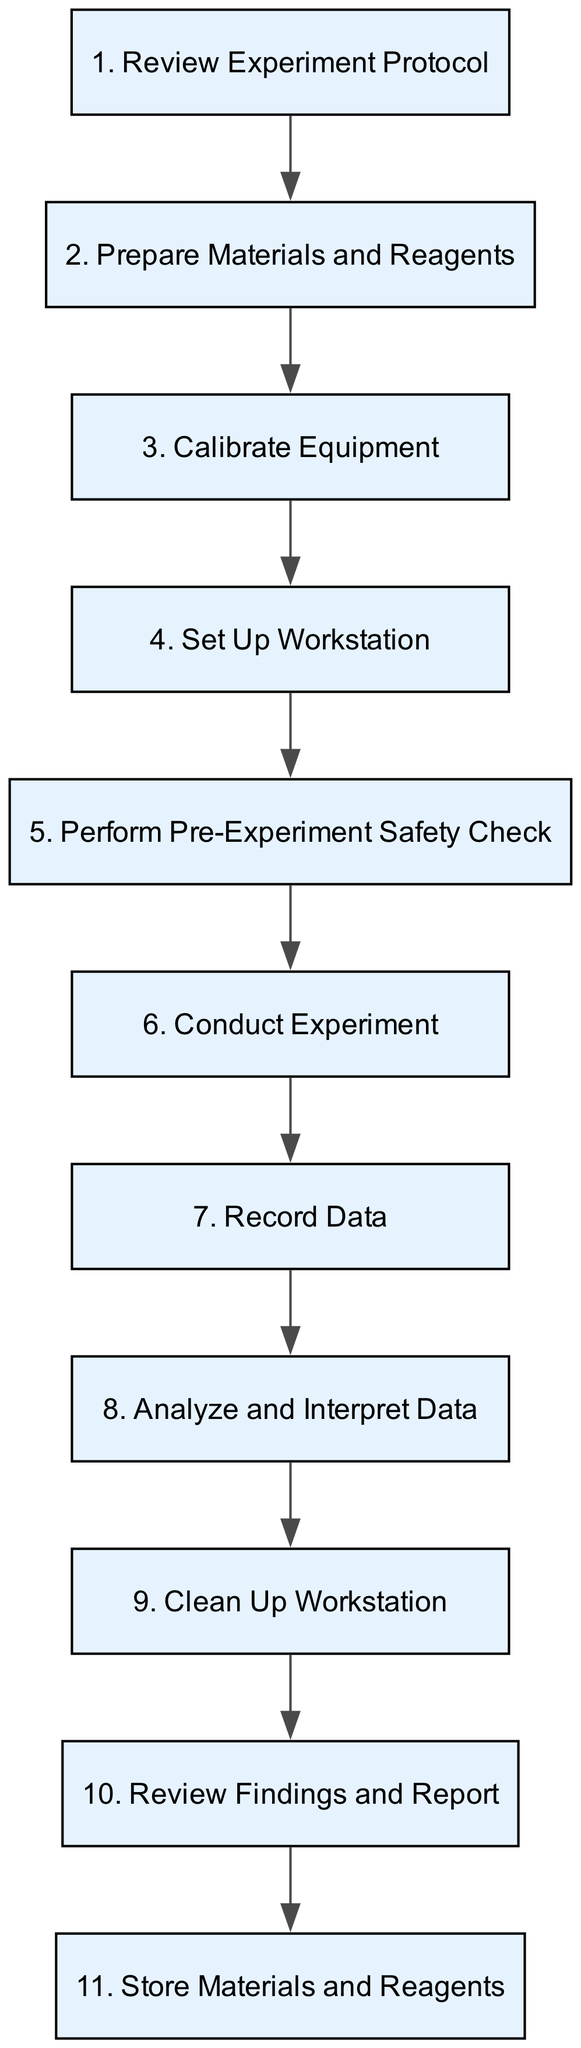What is the first step in the procedure? The first step, indicated at the top of the flowchart, is to 'Review Experiment Protocol.' This is the initial action before any other steps are taken.
Answer: Review Experiment Protocol How many steps are there in total? By counting all the nodes listed in the flowchart, there are eleven distinct steps, ranging from 'Review Experiment Protocol' to 'Store Materials and Reagents.'
Answer: eleven Which step follows 'Calibrate Equipment'? After 'Calibrate Equipment,' the next step is 'Set Up Workstation,' indicating the progression of tasks involved in managing the laboratory experiment.
Answer: Set Up Workstation What is the last step in this procedure? The last step in the flowchart is 'Store Materials and Reagents,' which shows that the procedure concludes with proper storage after the experiment.
Answer: Store Materials and Reagents What are the primary safety checks before conducting the experiment? The flowchart specifies conducting a 'Perform Pre-Experiment Safety Check' as the safety check to ensure all measures and PPE are in place, highlighting its importance before beginning the experiment.
Answer: Perform Pre-Experiment Safety Check Which step includes handling waste? The step that addresses waste management is 'Clean Up Workstation,' where proper disposal of waste is emphasized to maintain safety and cleanliness in the laboratory.
Answer: Clean Up Workstation Which two steps immediately precede 'Conduct Experiment'? The two steps that come immediately before 'Conduct Experiment' are 'Set Up Workstation' and 'Perform Pre-Experiment Safety Check.' This sequence ensures readiness before executing the actual experiment.
Answer: Set Up Workstation and Perform Pre-Experiment Safety Check What is required to ensure data reliability? According to the flowchart, 'Record Data' accurately is crucial for data reliability, emphasizing the importance of documentation throughout the experimental process.
Answer: Record Data 